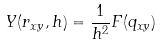<formula> <loc_0><loc_0><loc_500><loc_500>Y ( r _ { x y } , h ) = \frac { 1 } { h ^ { 2 } } F ( q _ { x y } )</formula> 